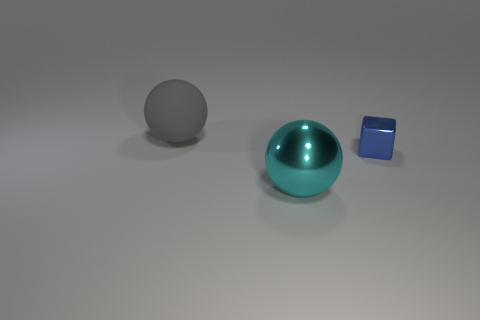Add 2 blue blocks. How many objects exist? 5 Subtract all balls. How many objects are left? 1 Add 1 rubber balls. How many rubber balls exist? 2 Subtract 0 cyan blocks. How many objects are left? 3 Subtract all large rubber spheres. Subtract all big cyan metallic spheres. How many objects are left? 1 Add 2 shiny things. How many shiny things are left? 4 